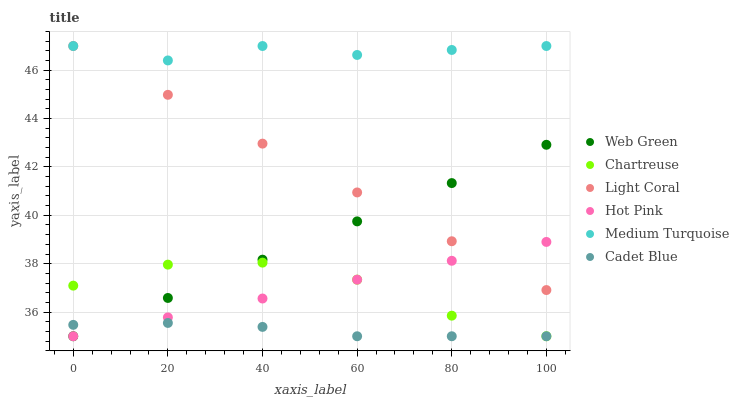Does Cadet Blue have the minimum area under the curve?
Answer yes or no. Yes. Does Medium Turquoise have the maximum area under the curve?
Answer yes or no. Yes. Does Hot Pink have the minimum area under the curve?
Answer yes or no. No. Does Hot Pink have the maximum area under the curve?
Answer yes or no. No. Is Web Green the smoothest?
Answer yes or no. Yes. Is Chartreuse the roughest?
Answer yes or no. Yes. Is Hot Pink the smoothest?
Answer yes or no. No. Is Hot Pink the roughest?
Answer yes or no. No. Does Cadet Blue have the lowest value?
Answer yes or no. Yes. Does Light Coral have the lowest value?
Answer yes or no. No. Does Medium Turquoise have the highest value?
Answer yes or no. Yes. Does Hot Pink have the highest value?
Answer yes or no. No. Is Cadet Blue less than Light Coral?
Answer yes or no. Yes. Is Medium Turquoise greater than Hot Pink?
Answer yes or no. Yes. Does Chartreuse intersect Hot Pink?
Answer yes or no. Yes. Is Chartreuse less than Hot Pink?
Answer yes or no. No. Is Chartreuse greater than Hot Pink?
Answer yes or no. No. Does Cadet Blue intersect Light Coral?
Answer yes or no. No. 